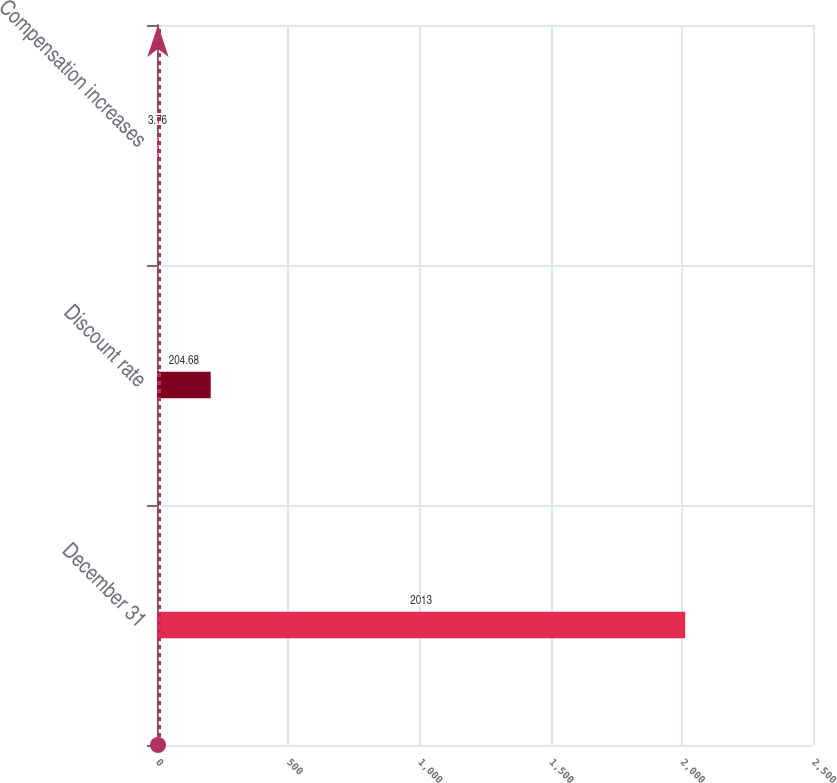Convert chart to OTSL. <chart><loc_0><loc_0><loc_500><loc_500><bar_chart><fcel>December 31<fcel>Discount rate<fcel>Compensation increases<nl><fcel>2013<fcel>204.68<fcel>3.76<nl></chart> 